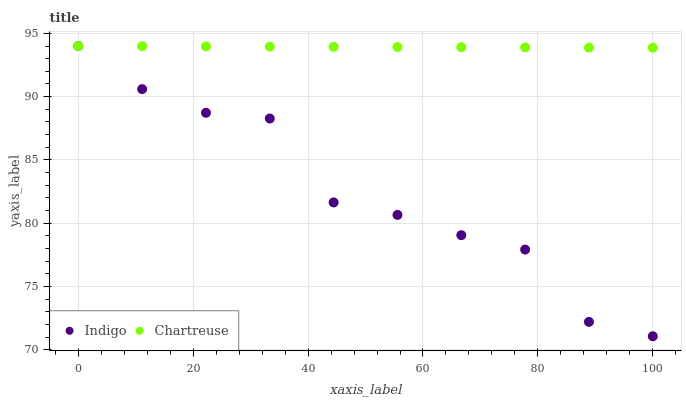Does Indigo have the minimum area under the curve?
Answer yes or no. Yes. Does Chartreuse have the maximum area under the curve?
Answer yes or no. Yes. Does Indigo have the maximum area under the curve?
Answer yes or no. No. Is Chartreuse the smoothest?
Answer yes or no. Yes. Is Indigo the roughest?
Answer yes or no. Yes. Is Indigo the smoothest?
Answer yes or no. No. Does Indigo have the lowest value?
Answer yes or no. Yes. Does Indigo have the highest value?
Answer yes or no. Yes. Does Indigo intersect Chartreuse?
Answer yes or no. Yes. Is Indigo less than Chartreuse?
Answer yes or no. No. Is Indigo greater than Chartreuse?
Answer yes or no. No. 